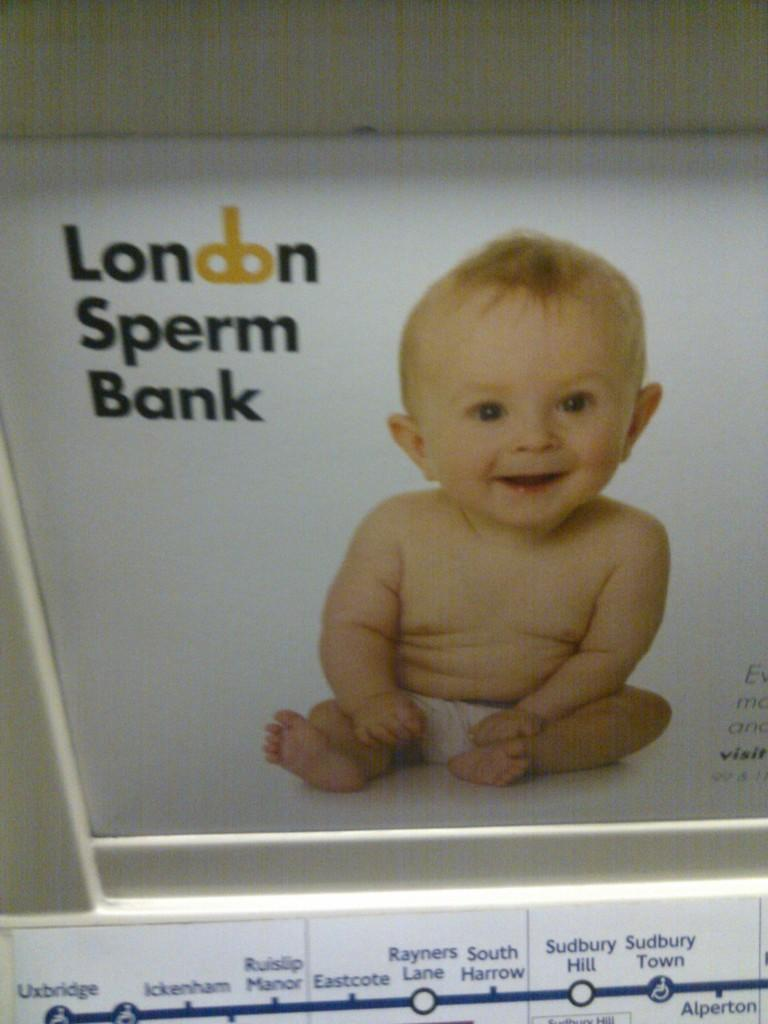What is the main subject of the poster in the image? The poster contains a picture of a baby. What else can be seen on the poster besides the picture? There is text on the poster. What is the tendency of the pollution in the image? There is no mention of pollution in the image, as the facts provided only discuss a poster with a picture of a baby and accompanying text. 